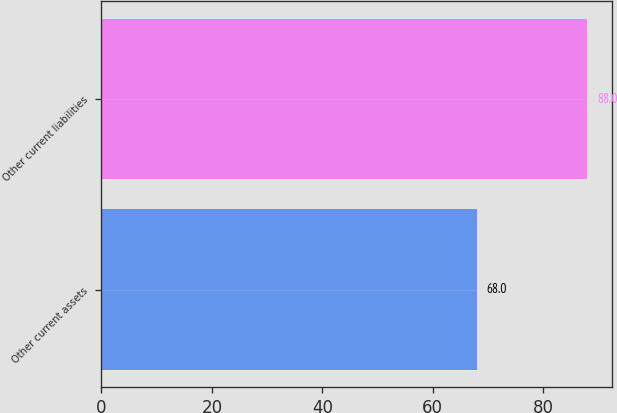Convert chart. <chart><loc_0><loc_0><loc_500><loc_500><bar_chart><fcel>Other current assets<fcel>Other current liabilities<nl><fcel>68<fcel>88<nl></chart> 